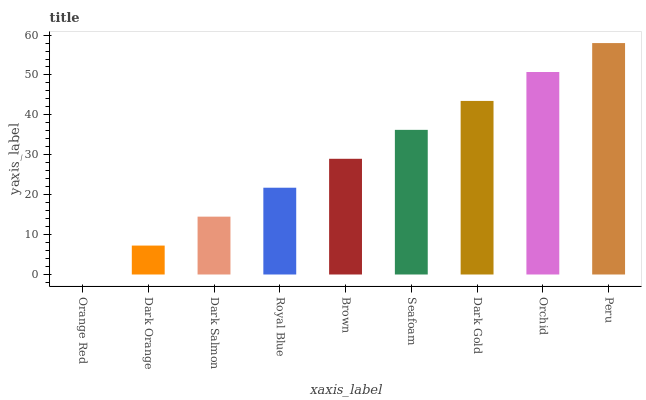Is Orange Red the minimum?
Answer yes or no. Yes. Is Peru the maximum?
Answer yes or no. Yes. Is Dark Orange the minimum?
Answer yes or no. No. Is Dark Orange the maximum?
Answer yes or no. No. Is Dark Orange greater than Orange Red?
Answer yes or no. Yes. Is Orange Red less than Dark Orange?
Answer yes or no. Yes. Is Orange Red greater than Dark Orange?
Answer yes or no. No. Is Dark Orange less than Orange Red?
Answer yes or no. No. Is Brown the high median?
Answer yes or no. Yes. Is Brown the low median?
Answer yes or no. Yes. Is Dark Orange the high median?
Answer yes or no. No. Is Peru the low median?
Answer yes or no. No. 